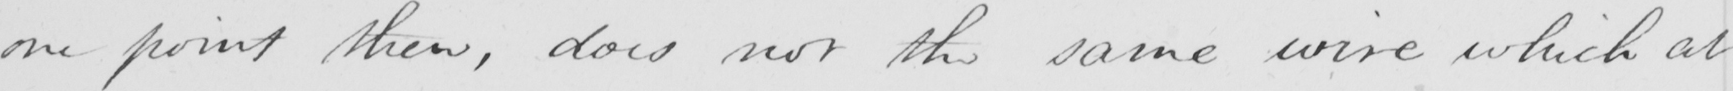What does this handwritten line say? one point then , does not the same wire which at 